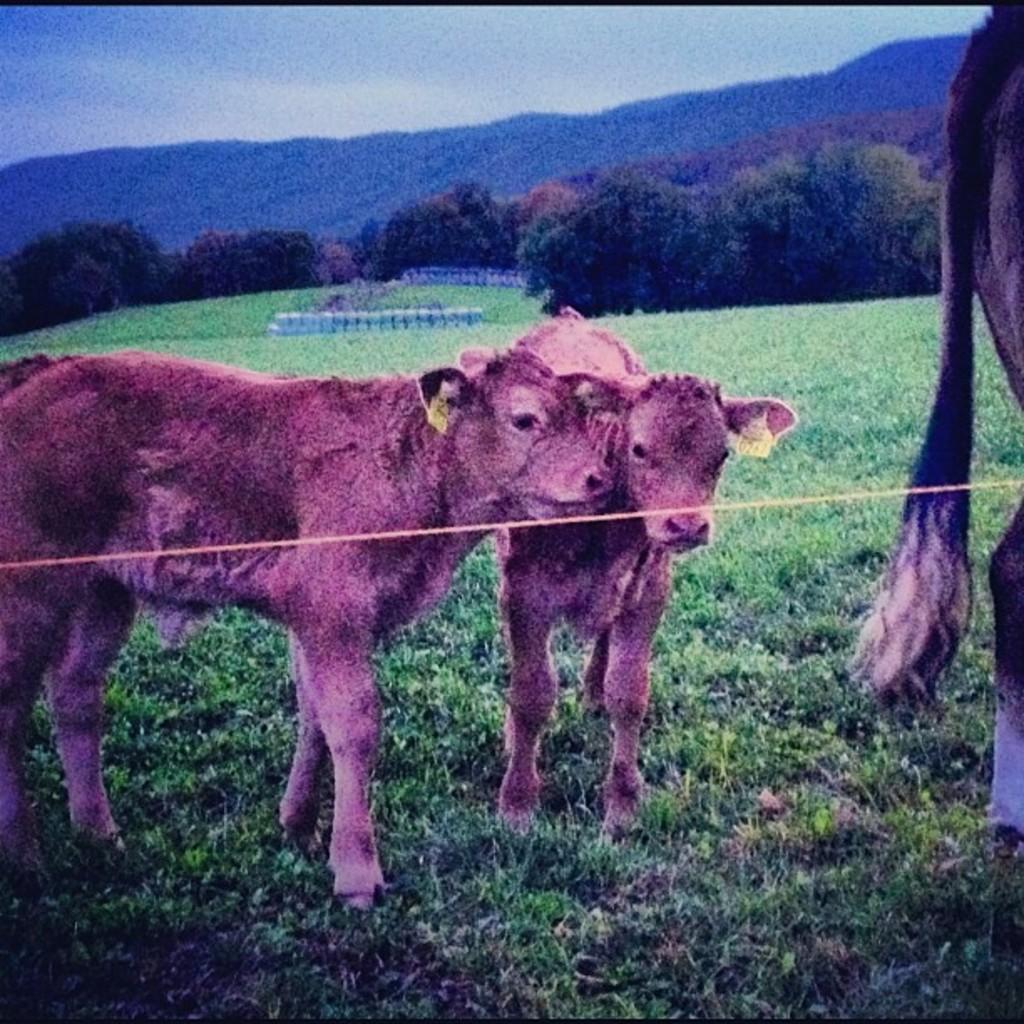In one or two sentences, can you explain what this image depicts? In the image there is a rope and behind the rope there are two calves standing on the grass and on the right side there is another animal, in the background there are trees and mountains. 